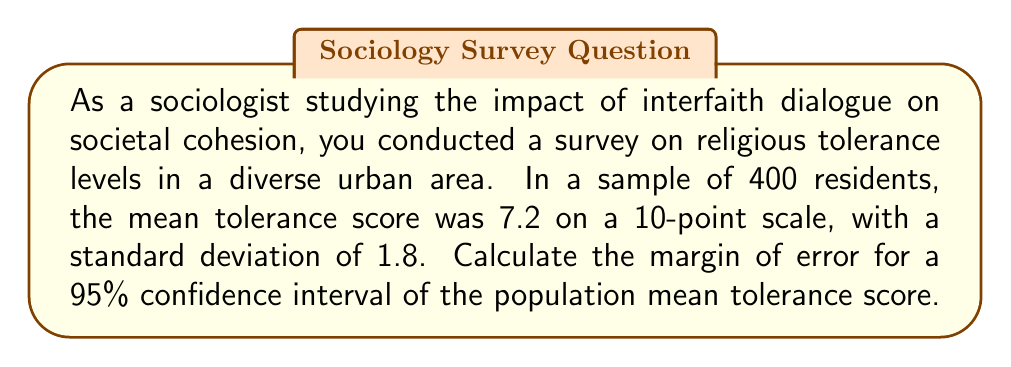Teach me how to tackle this problem. To calculate the margin of error for a 95% confidence interval, we'll follow these steps:

1. Identify the known values:
   - Sample size (n) = 400
   - Sample mean (x̄) = 7.2
   - Sample standard deviation (s) = 1.8
   - Confidence level = 95% (z-score = 1.96)

2. Use the formula for margin of error (ME):

   $$ ME = z \cdot \frac{s}{\sqrt{n}} $$

   Where:
   - z is the z-score for the desired confidence level
   - s is the sample standard deviation
   - n is the sample size

3. Substitute the values into the formula:

   $$ ME = 1.96 \cdot \frac{1.8}{\sqrt{400}} $$

4. Simplify:
   $$ ME = 1.96 \cdot \frac{1.8}{20} = 1.96 \cdot 0.09 = 0.1764 $$

5. Round to three decimal places:
   $$ ME \approx 0.176 $$

This means that we can be 95% confident that the true population mean tolerance score falls within ±0.176 points of our sample mean.
Answer: 0.176 